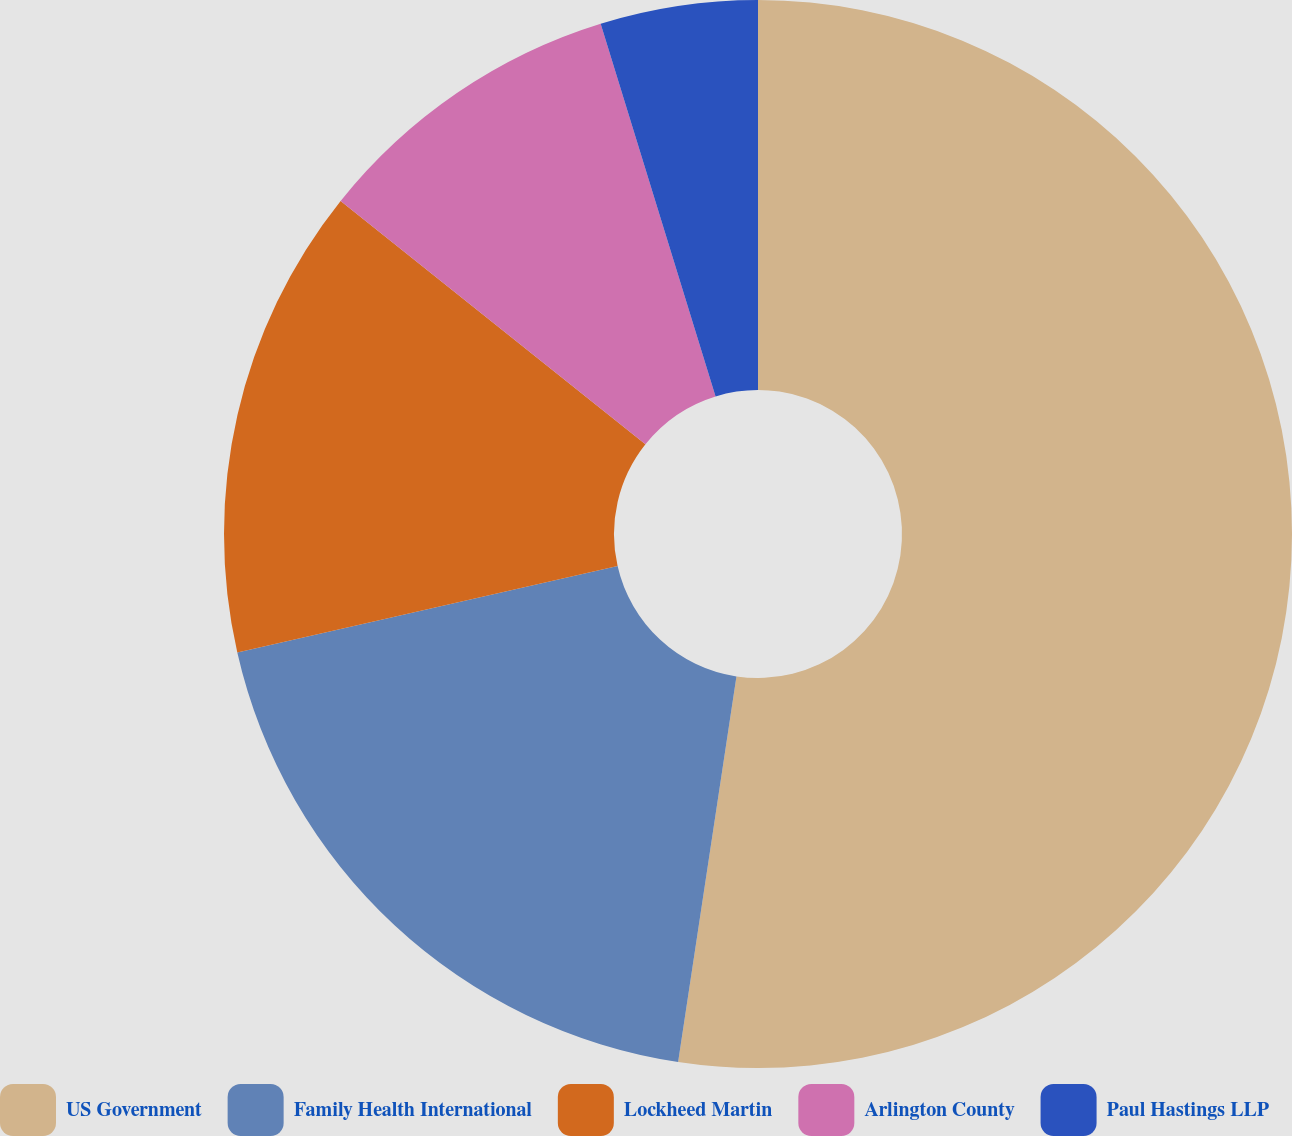<chart> <loc_0><loc_0><loc_500><loc_500><pie_chart><fcel>US Government<fcel>Family Health International<fcel>Lockheed Martin<fcel>Arlington County<fcel>Paul Hastings LLP<nl><fcel>52.39%<fcel>19.05%<fcel>14.28%<fcel>9.52%<fcel>4.76%<nl></chart> 